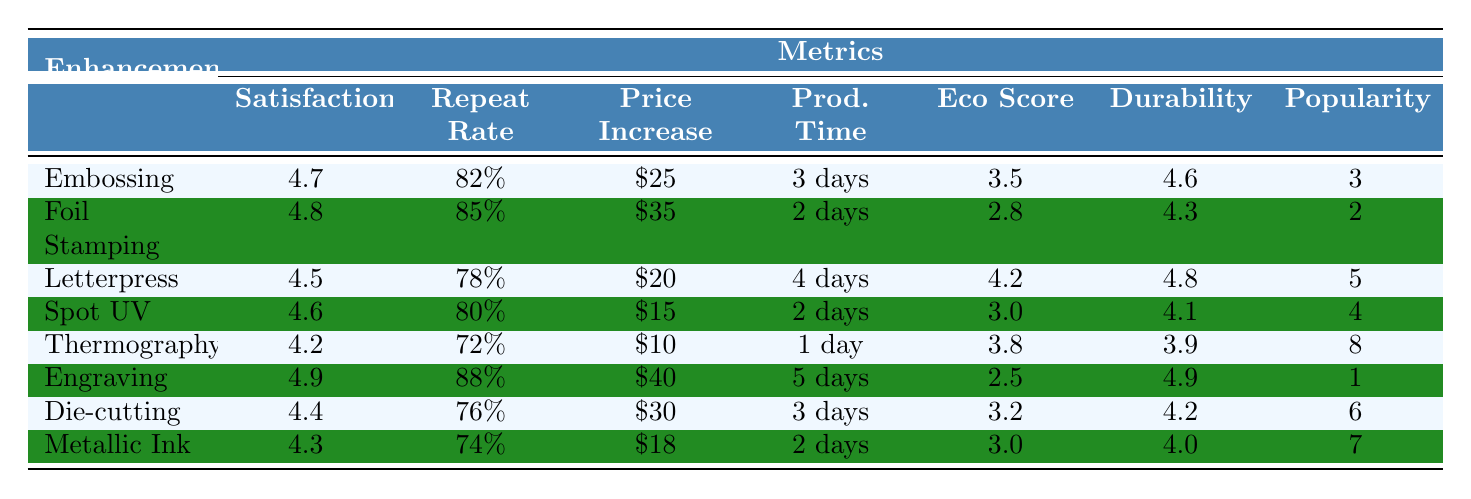What is the customer satisfaction score for Engraving? The table shows that the customer satisfaction score for Engraving is 4.9.
Answer: 4.9 Which enhancement technique has the highest repeat customer rate? Engraving has the highest repeat customer rate at 88%.
Answer: Engraving What is the average production time for Spot UV and Letterpress? The production time for Spot UV is 2 days and for Letterpress is 4 days. Summing these gives 6 days, and the average is 6/2 = 3 days.
Answer: 3 days Is Thermography the enhancement technique with the lowest customer satisfaction score? Looking at the scores, Thermography has a customer satisfaction score of 4.2, which is lower than Letterpress (4.5) and average compared to others, but it is not the lowest; that is Letterpress (4.5).
Answer: No What is the difference between the average price increase of Foil Stamping and Embossing? Foil Stamping has a price increase of $35 while Embossing has $25. The difference is 35 - 25 = 10.
Answer: $10 Which enhancement technique has the highest durability rating? Engraving has the highest durability rating at 4.9 based on the table.
Answer: Engraving If we combine the eco-friendliness scores of Spot UV and Metallic Ink, what will the total be? Spot UV has an eco-friendly score of 3.0 and Metallic Ink has a score of 3.0. The total score is 3.0 + 3.0 = 6.0.
Answer: 6.0 What is the popularity ranking of Letterpress and how does it compare to Thermography? Letterpress is ranked 5th and Thermography is ranked 8th. This means Letterpress is more popular than Thermography.
Answer: 5th Which enhancement technique has the lowest eco-friendliness score and what is the score? The lowest eco-friendliness score is for Engraving at 2.5.
Answer: 2.5 What is the average customer satisfaction score for all the techniques? Adding all scores: 4.7 + 4.8 + 4.5 + 4.6 + 4.2 + 4.9 + 4.4 + 4.3 = 36.4. There are 8 techniques, so the average is 36.4 / 8 = 4.55.
Answer: 4.55 